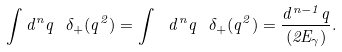Convert formula to latex. <formula><loc_0><loc_0><loc_500><loc_500>\int d ^ { n } q \ \delta _ { + } ( q ^ { 2 } ) = \int \ d ^ { n } q \ \delta _ { + } ( q ^ { 2 } ) = \frac { d ^ { n - 1 } q } { ( 2 E _ { \gamma } ) } .</formula> 